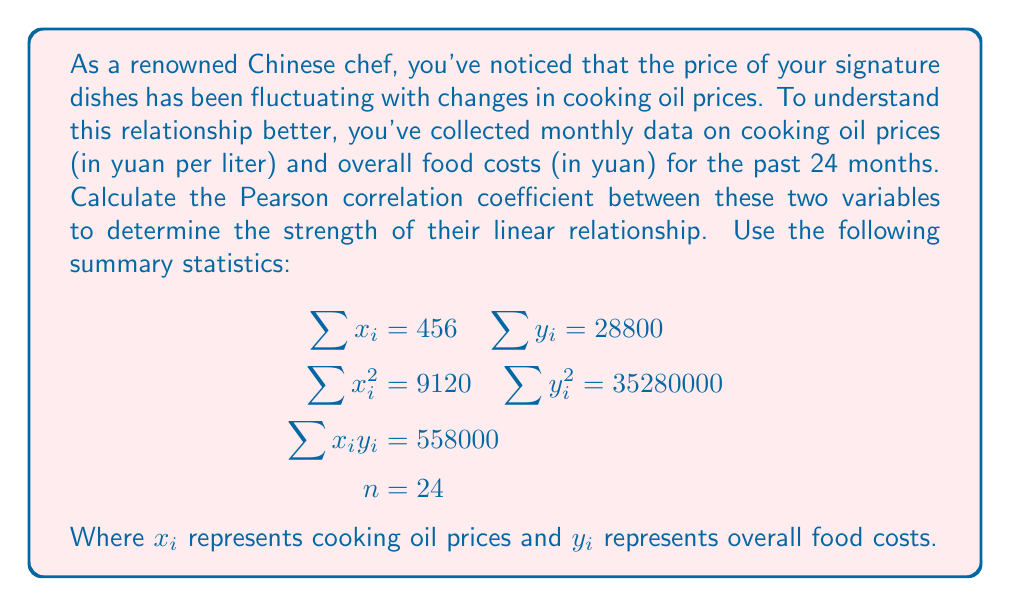Show me your answer to this math problem. To calculate the Pearson correlation coefficient (r), we'll use the formula:

$$r = \frac{n\sum x_iy_i - \sum x_i \sum y_i}{\sqrt{[n\sum x_i^2 - (\sum x_i)^2][n\sum y_i^2 - (\sum y_i)^2]}}$$

Let's calculate each component:

1. $n\sum x_iy_i = 24 \times 558000 = 13392000$
2. $\sum x_i \sum y_i = 456 \times 28800 = 13132800$
3. $n\sum x_i^2 = 24 \times 9120 = 218880$
4. $(\sum x_i)^2 = 456^2 = 207936$
5. $n\sum y_i^2 = 24 \times 35280000 = 846720000$
6. $(\sum y_i)^2 = 28800^2 = 829440000$

Now, let's substitute these values into the formula:

$$\begin{align*}
r &= \frac{13392000 - 13132800}{\sqrt{(218880 - 207936)(846720000 - 829440000)}} \\
&= \frac{259200}{\sqrt{(10944)(17280000)}} \\
&= \frac{259200}{\sqrt{189112320000}} \\
&= \frac{259200}{435444.7} \\
&\approx 0.5952
\end{align*}$$
Answer: The Pearson correlation coefficient between Chinese cooking oil prices and overall food costs is approximately 0.5952. 